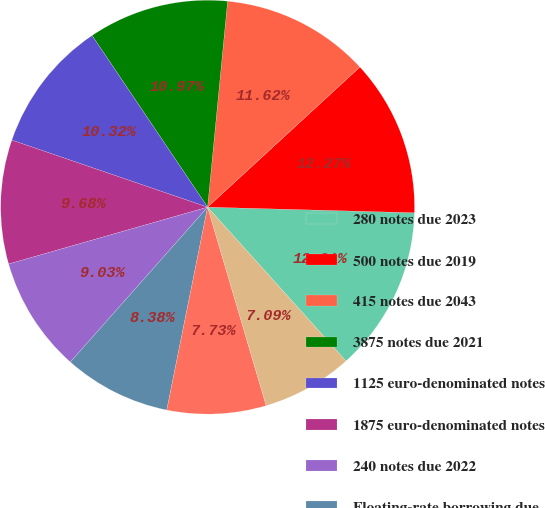<chart> <loc_0><loc_0><loc_500><loc_500><pie_chart><fcel>280 notes due 2023<fcel>500 notes due 2019<fcel>415 notes due 2043<fcel>3875 notes due 2021<fcel>1125 euro-denominated notes<fcel>1875 euro-denominated notes<fcel>240 notes due 2022<fcel>Floating-rate borrowing due<fcel>110 notes due 2018<fcel>130 notes due 2018<nl><fcel>12.91%<fcel>12.27%<fcel>11.62%<fcel>10.97%<fcel>10.32%<fcel>9.68%<fcel>9.03%<fcel>8.38%<fcel>7.73%<fcel>7.09%<nl></chart> 